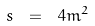Convert formula to latex. <formula><loc_0><loc_0><loc_500><loc_500>s \ = \ 4 m ^ { 2 }</formula> 